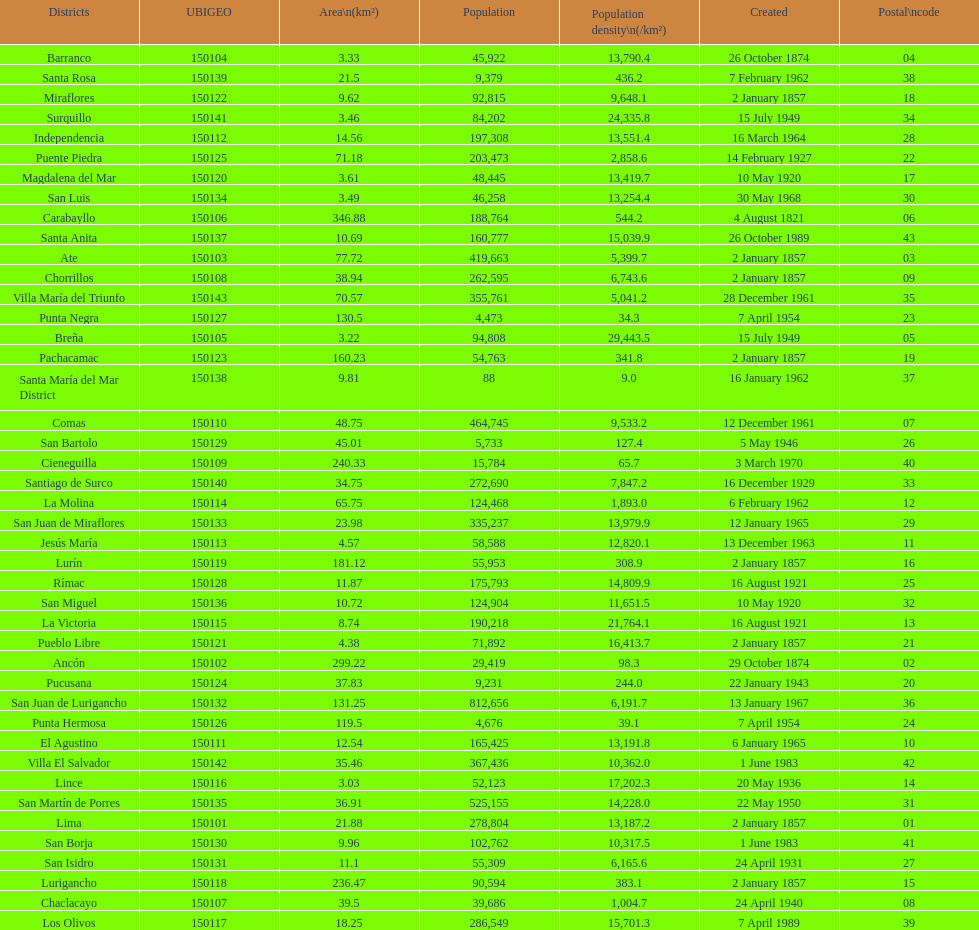What is the total number of districts of lima? 43. 